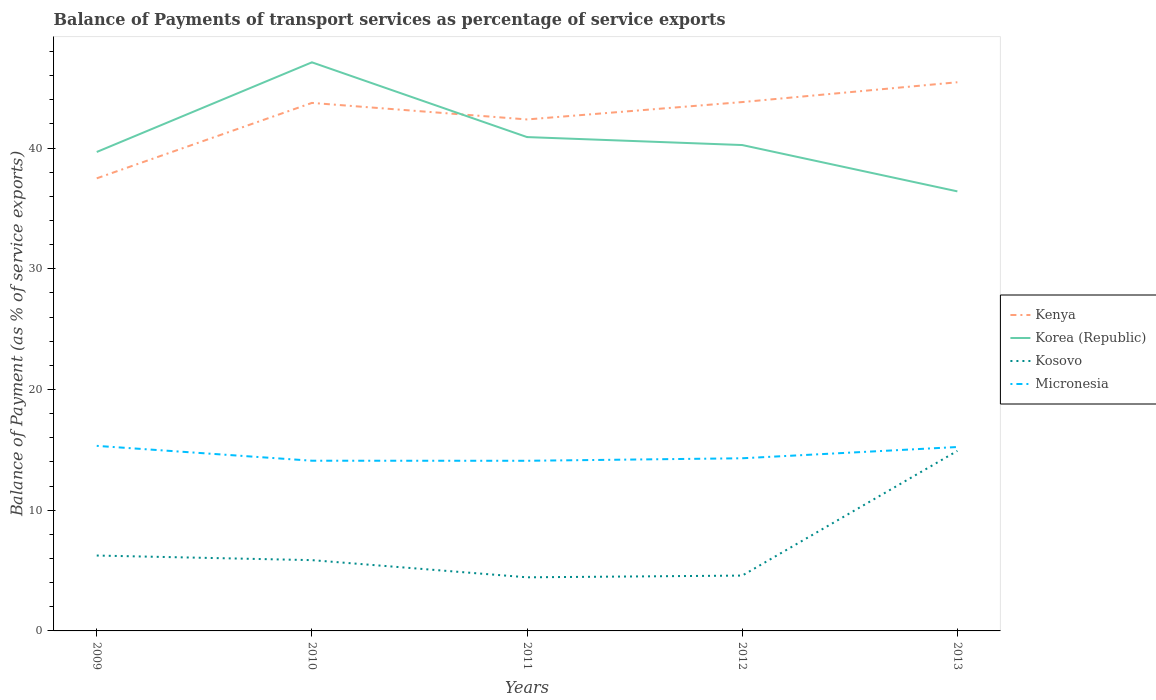How many different coloured lines are there?
Make the answer very short. 4. Across all years, what is the maximum balance of payments of transport services in Korea (Republic)?
Provide a short and direct response. 36.41. What is the total balance of payments of transport services in Korea (Republic) in the graph?
Your response must be concise. 0.66. What is the difference between the highest and the second highest balance of payments of transport services in Kenya?
Make the answer very short. 7.96. What is the difference between the highest and the lowest balance of payments of transport services in Korea (Republic)?
Keep it short and to the point. 2. How many years are there in the graph?
Your answer should be compact. 5. What is the difference between two consecutive major ticks on the Y-axis?
Your response must be concise. 10. Are the values on the major ticks of Y-axis written in scientific E-notation?
Give a very brief answer. No. How many legend labels are there?
Ensure brevity in your answer.  4. What is the title of the graph?
Provide a short and direct response. Balance of Payments of transport services as percentage of service exports. What is the label or title of the X-axis?
Provide a short and direct response. Years. What is the label or title of the Y-axis?
Offer a terse response. Balance of Payment (as % of service exports). What is the Balance of Payment (as % of service exports) of Kenya in 2009?
Your answer should be compact. 37.49. What is the Balance of Payment (as % of service exports) in Korea (Republic) in 2009?
Make the answer very short. 39.67. What is the Balance of Payment (as % of service exports) in Kosovo in 2009?
Your answer should be very brief. 6.24. What is the Balance of Payment (as % of service exports) in Micronesia in 2009?
Make the answer very short. 15.33. What is the Balance of Payment (as % of service exports) of Kenya in 2010?
Provide a short and direct response. 43.74. What is the Balance of Payment (as % of service exports) in Korea (Republic) in 2010?
Your answer should be compact. 47.1. What is the Balance of Payment (as % of service exports) in Kosovo in 2010?
Make the answer very short. 5.86. What is the Balance of Payment (as % of service exports) of Micronesia in 2010?
Provide a succinct answer. 14.1. What is the Balance of Payment (as % of service exports) of Kenya in 2011?
Give a very brief answer. 42.37. What is the Balance of Payment (as % of service exports) of Korea (Republic) in 2011?
Offer a very short reply. 40.91. What is the Balance of Payment (as % of service exports) in Kosovo in 2011?
Your response must be concise. 4.44. What is the Balance of Payment (as % of service exports) of Micronesia in 2011?
Ensure brevity in your answer.  14.09. What is the Balance of Payment (as % of service exports) of Kenya in 2012?
Offer a terse response. 43.81. What is the Balance of Payment (as % of service exports) of Korea (Republic) in 2012?
Your answer should be compact. 40.25. What is the Balance of Payment (as % of service exports) of Kosovo in 2012?
Ensure brevity in your answer.  4.58. What is the Balance of Payment (as % of service exports) of Micronesia in 2012?
Offer a terse response. 14.3. What is the Balance of Payment (as % of service exports) of Kenya in 2013?
Your answer should be compact. 45.45. What is the Balance of Payment (as % of service exports) of Korea (Republic) in 2013?
Your answer should be compact. 36.41. What is the Balance of Payment (as % of service exports) in Kosovo in 2013?
Ensure brevity in your answer.  14.91. What is the Balance of Payment (as % of service exports) of Micronesia in 2013?
Your answer should be very brief. 15.23. Across all years, what is the maximum Balance of Payment (as % of service exports) in Kenya?
Make the answer very short. 45.45. Across all years, what is the maximum Balance of Payment (as % of service exports) of Korea (Republic)?
Keep it short and to the point. 47.1. Across all years, what is the maximum Balance of Payment (as % of service exports) of Kosovo?
Ensure brevity in your answer.  14.91. Across all years, what is the maximum Balance of Payment (as % of service exports) in Micronesia?
Your response must be concise. 15.33. Across all years, what is the minimum Balance of Payment (as % of service exports) in Kenya?
Provide a succinct answer. 37.49. Across all years, what is the minimum Balance of Payment (as % of service exports) in Korea (Republic)?
Offer a very short reply. 36.41. Across all years, what is the minimum Balance of Payment (as % of service exports) in Kosovo?
Your answer should be compact. 4.44. Across all years, what is the minimum Balance of Payment (as % of service exports) in Micronesia?
Give a very brief answer. 14.09. What is the total Balance of Payment (as % of service exports) in Kenya in the graph?
Your response must be concise. 212.85. What is the total Balance of Payment (as % of service exports) in Korea (Republic) in the graph?
Offer a very short reply. 204.34. What is the total Balance of Payment (as % of service exports) of Kosovo in the graph?
Provide a succinct answer. 36.05. What is the total Balance of Payment (as % of service exports) of Micronesia in the graph?
Your answer should be compact. 73.06. What is the difference between the Balance of Payment (as % of service exports) of Kenya in 2009 and that in 2010?
Keep it short and to the point. -6.25. What is the difference between the Balance of Payment (as % of service exports) of Korea (Republic) in 2009 and that in 2010?
Offer a very short reply. -7.43. What is the difference between the Balance of Payment (as % of service exports) in Kosovo in 2009 and that in 2010?
Offer a very short reply. 0.38. What is the difference between the Balance of Payment (as % of service exports) in Micronesia in 2009 and that in 2010?
Your response must be concise. 1.23. What is the difference between the Balance of Payment (as % of service exports) of Kenya in 2009 and that in 2011?
Make the answer very short. -4.88. What is the difference between the Balance of Payment (as % of service exports) of Korea (Republic) in 2009 and that in 2011?
Provide a succinct answer. -1.23. What is the difference between the Balance of Payment (as % of service exports) in Kosovo in 2009 and that in 2011?
Ensure brevity in your answer.  1.8. What is the difference between the Balance of Payment (as % of service exports) in Micronesia in 2009 and that in 2011?
Keep it short and to the point. 1.24. What is the difference between the Balance of Payment (as % of service exports) of Kenya in 2009 and that in 2012?
Provide a short and direct response. -6.32. What is the difference between the Balance of Payment (as % of service exports) in Korea (Republic) in 2009 and that in 2012?
Offer a terse response. -0.57. What is the difference between the Balance of Payment (as % of service exports) in Kosovo in 2009 and that in 2012?
Keep it short and to the point. 1.66. What is the difference between the Balance of Payment (as % of service exports) in Micronesia in 2009 and that in 2012?
Keep it short and to the point. 1.03. What is the difference between the Balance of Payment (as % of service exports) in Kenya in 2009 and that in 2013?
Make the answer very short. -7.96. What is the difference between the Balance of Payment (as % of service exports) of Korea (Republic) in 2009 and that in 2013?
Offer a very short reply. 3.26. What is the difference between the Balance of Payment (as % of service exports) in Kosovo in 2009 and that in 2013?
Offer a very short reply. -8.67. What is the difference between the Balance of Payment (as % of service exports) of Micronesia in 2009 and that in 2013?
Provide a short and direct response. 0.1. What is the difference between the Balance of Payment (as % of service exports) in Kenya in 2010 and that in 2011?
Ensure brevity in your answer.  1.37. What is the difference between the Balance of Payment (as % of service exports) of Korea (Republic) in 2010 and that in 2011?
Provide a succinct answer. 6.19. What is the difference between the Balance of Payment (as % of service exports) of Kosovo in 2010 and that in 2011?
Ensure brevity in your answer.  1.42. What is the difference between the Balance of Payment (as % of service exports) of Micronesia in 2010 and that in 2011?
Offer a very short reply. 0.01. What is the difference between the Balance of Payment (as % of service exports) of Kenya in 2010 and that in 2012?
Your response must be concise. -0.07. What is the difference between the Balance of Payment (as % of service exports) in Korea (Republic) in 2010 and that in 2012?
Offer a terse response. 6.85. What is the difference between the Balance of Payment (as % of service exports) of Kosovo in 2010 and that in 2012?
Your response must be concise. 1.28. What is the difference between the Balance of Payment (as % of service exports) of Micronesia in 2010 and that in 2012?
Ensure brevity in your answer.  -0.2. What is the difference between the Balance of Payment (as % of service exports) of Kenya in 2010 and that in 2013?
Ensure brevity in your answer.  -1.71. What is the difference between the Balance of Payment (as % of service exports) in Korea (Republic) in 2010 and that in 2013?
Provide a succinct answer. 10.69. What is the difference between the Balance of Payment (as % of service exports) of Kosovo in 2010 and that in 2013?
Keep it short and to the point. -9.05. What is the difference between the Balance of Payment (as % of service exports) in Micronesia in 2010 and that in 2013?
Ensure brevity in your answer.  -1.14. What is the difference between the Balance of Payment (as % of service exports) in Kenya in 2011 and that in 2012?
Offer a very short reply. -1.44. What is the difference between the Balance of Payment (as % of service exports) of Korea (Republic) in 2011 and that in 2012?
Make the answer very short. 0.66. What is the difference between the Balance of Payment (as % of service exports) of Kosovo in 2011 and that in 2012?
Provide a succinct answer. -0.14. What is the difference between the Balance of Payment (as % of service exports) in Micronesia in 2011 and that in 2012?
Offer a terse response. -0.21. What is the difference between the Balance of Payment (as % of service exports) of Kenya in 2011 and that in 2013?
Provide a short and direct response. -3.08. What is the difference between the Balance of Payment (as % of service exports) in Korea (Republic) in 2011 and that in 2013?
Keep it short and to the point. 4.5. What is the difference between the Balance of Payment (as % of service exports) of Kosovo in 2011 and that in 2013?
Make the answer very short. -10.47. What is the difference between the Balance of Payment (as % of service exports) in Micronesia in 2011 and that in 2013?
Your response must be concise. -1.14. What is the difference between the Balance of Payment (as % of service exports) in Kenya in 2012 and that in 2013?
Keep it short and to the point. -1.64. What is the difference between the Balance of Payment (as % of service exports) in Korea (Republic) in 2012 and that in 2013?
Provide a short and direct response. 3.84. What is the difference between the Balance of Payment (as % of service exports) in Kosovo in 2012 and that in 2013?
Your answer should be very brief. -10.33. What is the difference between the Balance of Payment (as % of service exports) in Micronesia in 2012 and that in 2013?
Provide a short and direct response. -0.93. What is the difference between the Balance of Payment (as % of service exports) of Kenya in 2009 and the Balance of Payment (as % of service exports) of Korea (Republic) in 2010?
Offer a terse response. -9.61. What is the difference between the Balance of Payment (as % of service exports) of Kenya in 2009 and the Balance of Payment (as % of service exports) of Kosovo in 2010?
Your answer should be very brief. 31.63. What is the difference between the Balance of Payment (as % of service exports) of Kenya in 2009 and the Balance of Payment (as % of service exports) of Micronesia in 2010?
Provide a succinct answer. 23.39. What is the difference between the Balance of Payment (as % of service exports) of Korea (Republic) in 2009 and the Balance of Payment (as % of service exports) of Kosovo in 2010?
Offer a terse response. 33.81. What is the difference between the Balance of Payment (as % of service exports) of Korea (Republic) in 2009 and the Balance of Payment (as % of service exports) of Micronesia in 2010?
Your answer should be compact. 25.57. What is the difference between the Balance of Payment (as % of service exports) in Kosovo in 2009 and the Balance of Payment (as % of service exports) in Micronesia in 2010?
Make the answer very short. -7.85. What is the difference between the Balance of Payment (as % of service exports) in Kenya in 2009 and the Balance of Payment (as % of service exports) in Korea (Republic) in 2011?
Your response must be concise. -3.42. What is the difference between the Balance of Payment (as % of service exports) of Kenya in 2009 and the Balance of Payment (as % of service exports) of Kosovo in 2011?
Your answer should be compact. 33.05. What is the difference between the Balance of Payment (as % of service exports) of Kenya in 2009 and the Balance of Payment (as % of service exports) of Micronesia in 2011?
Your answer should be compact. 23.4. What is the difference between the Balance of Payment (as % of service exports) of Korea (Republic) in 2009 and the Balance of Payment (as % of service exports) of Kosovo in 2011?
Offer a terse response. 35.23. What is the difference between the Balance of Payment (as % of service exports) of Korea (Republic) in 2009 and the Balance of Payment (as % of service exports) of Micronesia in 2011?
Make the answer very short. 25.58. What is the difference between the Balance of Payment (as % of service exports) in Kosovo in 2009 and the Balance of Payment (as % of service exports) in Micronesia in 2011?
Provide a short and direct response. -7.85. What is the difference between the Balance of Payment (as % of service exports) of Kenya in 2009 and the Balance of Payment (as % of service exports) of Korea (Republic) in 2012?
Provide a short and direct response. -2.76. What is the difference between the Balance of Payment (as % of service exports) of Kenya in 2009 and the Balance of Payment (as % of service exports) of Kosovo in 2012?
Offer a terse response. 32.91. What is the difference between the Balance of Payment (as % of service exports) of Kenya in 2009 and the Balance of Payment (as % of service exports) of Micronesia in 2012?
Provide a short and direct response. 23.19. What is the difference between the Balance of Payment (as % of service exports) of Korea (Republic) in 2009 and the Balance of Payment (as % of service exports) of Kosovo in 2012?
Your response must be concise. 35.09. What is the difference between the Balance of Payment (as % of service exports) of Korea (Republic) in 2009 and the Balance of Payment (as % of service exports) of Micronesia in 2012?
Give a very brief answer. 25.37. What is the difference between the Balance of Payment (as % of service exports) of Kosovo in 2009 and the Balance of Payment (as % of service exports) of Micronesia in 2012?
Your response must be concise. -8.06. What is the difference between the Balance of Payment (as % of service exports) of Kenya in 2009 and the Balance of Payment (as % of service exports) of Korea (Republic) in 2013?
Make the answer very short. 1.08. What is the difference between the Balance of Payment (as % of service exports) in Kenya in 2009 and the Balance of Payment (as % of service exports) in Kosovo in 2013?
Provide a short and direct response. 22.58. What is the difference between the Balance of Payment (as % of service exports) in Kenya in 2009 and the Balance of Payment (as % of service exports) in Micronesia in 2013?
Your answer should be very brief. 22.26. What is the difference between the Balance of Payment (as % of service exports) of Korea (Republic) in 2009 and the Balance of Payment (as % of service exports) of Kosovo in 2013?
Ensure brevity in your answer.  24.76. What is the difference between the Balance of Payment (as % of service exports) in Korea (Republic) in 2009 and the Balance of Payment (as % of service exports) in Micronesia in 2013?
Your answer should be compact. 24.44. What is the difference between the Balance of Payment (as % of service exports) of Kosovo in 2009 and the Balance of Payment (as % of service exports) of Micronesia in 2013?
Ensure brevity in your answer.  -8.99. What is the difference between the Balance of Payment (as % of service exports) of Kenya in 2010 and the Balance of Payment (as % of service exports) of Korea (Republic) in 2011?
Provide a short and direct response. 2.83. What is the difference between the Balance of Payment (as % of service exports) of Kenya in 2010 and the Balance of Payment (as % of service exports) of Kosovo in 2011?
Give a very brief answer. 39.3. What is the difference between the Balance of Payment (as % of service exports) in Kenya in 2010 and the Balance of Payment (as % of service exports) in Micronesia in 2011?
Offer a terse response. 29.64. What is the difference between the Balance of Payment (as % of service exports) of Korea (Republic) in 2010 and the Balance of Payment (as % of service exports) of Kosovo in 2011?
Provide a short and direct response. 42.66. What is the difference between the Balance of Payment (as % of service exports) in Korea (Republic) in 2010 and the Balance of Payment (as % of service exports) in Micronesia in 2011?
Offer a terse response. 33.01. What is the difference between the Balance of Payment (as % of service exports) in Kosovo in 2010 and the Balance of Payment (as % of service exports) in Micronesia in 2011?
Your response must be concise. -8.23. What is the difference between the Balance of Payment (as % of service exports) of Kenya in 2010 and the Balance of Payment (as % of service exports) of Korea (Republic) in 2012?
Provide a short and direct response. 3.49. What is the difference between the Balance of Payment (as % of service exports) in Kenya in 2010 and the Balance of Payment (as % of service exports) in Kosovo in 2012?
Offer a terse response. 39.15. What is the difference between the Balance of Payment (as % of service exports) of Kenya in 2010 and the Balance of Payment (as % of service exports) of Micronesia in 2012?
Your answer should be very brief. 29.44. What is the difference between the Balance of Payment (as % of service exports) of Korea (Republic) in 2010 and the Balance of Payment (as % of service exports) of Kosovo in 2012?
Offer a terse response. 42.52. What is the difference between the Balance of Payment (as % of service exports) in Korea (Republic) in 2010 and the Balance of Payment (as % of service exports) in Micronesia in 2012?
Keep it short and to the point. 32.8. What is the difference between the Balance of Payment (as % of service exports) of Kosovo in 2010 and the Balance of Payment (as % of service exports) of Micronesia in 2012?
Ensure brevity in your answer.  -8.44. What is the difference between the Balance of Payment (as % of service exports) in Kenya in 2010 and the Balance of Payment (as % of service exports) in Korea (Republic) in 2013?
Give a very brief answer. 7.33. What is the difference between the Balance of Payment (as % of service exports) in Kenya in 2010 and the Balance of Payment (as % of service exports) in Kosovo in 2013?
Offer a very short reply. 28.82. What is the difference between the Balance of Payment (as % of service exports) of Kenya in 2010 and the Balance of Payment (as % of service exports) of Micronesia in 2013?
Your answer should be very brief. 28.5. What is the difference between the Balance of Payment (as % of service exports) in Korea (Republic) in 2010 and the Balance of Payment (as % of service exports) in Kosovo in 2013?
Offer a very short reply. 32.19. What is the difference between the Balance of Payment (as % of service exports) of Korea (Republic) in 2010 and the Balance of Payment (as % of service exports) of Micronesia in 2013?
Your answer should be very brief. 31.87. What is the difference between the Balance of Payment (as % of service exports) of Kosovo in 2010 and the Balance of Payment (as % of service exports) of Micronesia in 2013?
Provide a succinct answer. -9.37. What is the difference between the Balance of Payment (as % of service exports) of Kenya in 2011 and the Balance of Payment (as % of service exports) of Korea (Republic) in 2012?
Offer a terse response. 2.12. What is the difference between the Balance of Payment (as % of service exports) of Kenya in 2011 and the Balance of Payment (as % of service exports) of Kosovo in 2012?
Provide a short and direct response. 37.78. What is the difference between the Balance of Payment (as % of service exports) of Kenya in 2011 and the Balance of Payment (as % of service exports) of Micronesia in 2012?
Give a very brief answer. 28.07. What is the difference between the Balance of Payment (as % of service exports) of Korea (Republic) in 2011 and the Balance of Payment (as % of service exports) of Kosovo in 2012?
Your answer should be compact. 36.32. What is the difference between the Balance of Payment (as % of service exports) of Korea (Republic) in 2011 and the Balance of Payment (as % of service exports) of Micronesia in 2012?
Give a very brief answer. 26.61. What is the difference between the Balance of Payment (as % of service exports) in Kosovo in 2011 and the Balance of Payment (as % of service exports) in Micronesia in 2012?
Ensure brevity in your answer.  -9.86. What is the difference between the Balance of Payment (as % of service exports) in Kenya in 2011 and the Balance of Payment (as % of service exports) in Korea (Republic) in 2013?
Offer a very short reply. 5.96. What is the difference between the Balance of Payment (as % of service exports) of Kenya in 2011 and the Balance of Payment (as % of service exports) of Kosovo in 2013?
Offer a terse response. 27.45. What is the difference between the Balance of Payment (as % of service exports) in Kenya in 2011 and the Balance of Payment (as % of service exports) in Micronesia in 2013?
Your answer should be very brief. 27.13. What is the difference between the Balance of Payment (as % of service exports) in Korea (Republic) in 2011 and the Balance of Payment (as % of service exports) in Kosovo in 2013?
Your response must be concise. 25.99. What is the difference between the Balance of Payment (as % of service exports) of Korea (Republic) in 2011 and the Balance of Payment (as % of service exports) of Micronesia in 2013?
Your answer should be compact. 25.67. What is the difference between the Balance of Payment (as % of service exports) in Kosovo in 2011 and the Balance of Payment (as % of service exports) in Micronesia in 2013?
Provide a short and direct response. -10.79. What is the difference between the Balance of Payment (as % of service exports) in Kenya in 2012 and the Balance of Payment (as % of service exports) in Korea (Republic) in 2013?
Provide a succinct answer. 7.4. What is the difference between the Balance of Payment (as % of service exports) in Kenya in 2012 and the Balance of Payment (as % of service exports) in Kosovo in 2013?
Keep it short and to the point. 28.89. What is the difference between the Balance of Payment (as % of service exports) of Kenya in 2012 and the Balance of Payment (as % of service exports) of Micronesia in 2013?
Offer a very short reply. 28.57. What is the difference between the Balance of Payment (as % of service exports) of Korea (Republic) in 2012 and the Balance of Payment (as % of service exports) of Kosovo in 2013?
Offer a very short reply. 25.33. What is the difference between the Balance of Payment (as % of service exports) in Korea (Republic) in 2012 and the Balance of Payment (as % of service exports) in Micronesia in 2013?
Give a very brief answer. 25.01. What is the difference between the Balance of Payment (as % of service exports) of Kosovo in 2012 and the Balance of Payment (as % of service exports) of Micronesia in 2013?
Keep it short and to the point. -10.65. What is the average Balance of Payment (as % of service exports) in Kenya per year?
Offer a terse response. 42.57. What is the average Balance of Payment (as % of service exports) of Korea (Republic) per year?
Your answer should be very brief. 40.87. What is the average Balance of Payment (as % of service exports) of Kosovo per year?
Make the answer very short. 7.21. What is the average Balance of Payment (as % of service exports) of Micronesia per year?
Provide a short and direct response. 14.61. In the year 2009, what is the difference between the Balance of Payment (as % of service exports) of Kenya and Balance of Payment (as % of service exports) of Korea (Republic)?
Your answer should be very brief. -2.18. In the year 2009, what is the difference between the Balance of Payment (as % of service exports) of Kenya and Balance of Payment (as % of service exports) of Kosovo?
Provide a short and direct response. 31.25. In the year 2009, what is the difference between the Balance of Payment (as % of service exports) of Kenya and Balance of Payment (as % of service exports) of Micronesia?
Provide a succinct answer. 22.16. In the year 2009, what is the difference between the Balance of Payment (as % of service exports) in Korea (Republic) and Balance of Payment (as % of service exports) in Kosovo?
Offer a very short reply. 33.43. In the year 2009, what is the difference between the Balance of Payment (as % of service exports) of Korea (Republic) and Balance of Payment (as % of service exports) of Micronesia?
Your answer should be compact. 24.34. In the year 2009, what is the difference between the Balance of Payment (as % of service exports) in Kosovo and Balance of Payment (as % of service exports) in Micronesia?
Offer a very short reply. -9.08. In the year 2010, what is the difference between the Balance of Payment (as % of service exports) in Kenya and Balance of Payment (as % of service exports) in Korea (Republic)?
Your response must be concise. -3.36. In the year 2010, what is the difference between the Balance of Payment (as % of service exports) of Kenya and Balance of Payment (as % of service exports) of Kosovo?
Offer a very short reply. 37.87. In the year 2010, what is the difference between the Balance of Payment (as % of service exports) of Kenya and Balance of Payment (as % of service exports) of Micronesia?
Your response must be concise. 29.64. In the year 2010, what is the difference between the Balance of Payment (as % of service exports) in Korea (Republic) and Balance of Payment (as % of service exports) in Kosovo?
Keep it short and to the point. 41.24. In the year 2010, what is the difference between the Balance of Payment (as % of service exports) of Korea (Republic) and Balance of Payment (as % of service exports) of Micronesia?
Your answer should be compact. 33. In the year 2010, what is the difference between the Balance of Payment (as % of service exports) in Kosovo and Balance of Payment (as % of service exports) in Micronesia?
Offer a very short reply. -8.24. In the year 2011, what is the difference between the Balance of Payment (as % of service exports) in Kenya and Balance of Payment (as % of service exports) in Korea (Republic)?
Provide a succinct answer. 1.46. In the year 2011, what is the difference between the Balance of Payment (as % of service exports) of Kenya and Balance of Payment (as % of service exports) of Kosovo?
Give a very brief answer. 37.93. In the year 2011, what is the difference between the Balance of Payment (as % of service exports) in Kenya and Balance of Payment (as % of service exports) in Micronesia?
Your answer should be very brief. 28.27. In the year 2011, what is the difference between the Balance of Payment (as % of service exports) of Korea (Republic) and Balance of Payment (as % of service exports) of Kosovo?
Your answer should be compact. 36.47. In the year 2011, what is the difference between the Balance of Payment (as % of service exports) of Korea (Republic) and Balance of Payment (as % of service exports) of Micronesia?
Your answer should be very brief. 26.81. In the year 2011, what is the difference between the Balance of Payment (as % of service exports) of Kosovo and Balance of Payment (as % of service exports) of Micronesia?
Your response must be concise. -9.65. In the year 2012, what is the difference between the Balance of Payment (as % of service exports) in Kenya and Balance of Payment (as % of service exports) in Korea (Republic)?
Provide a succinct answer. 3.56. In the year 2012, what is the difference between the Balance of Payment (as % of service exports) of Kenya and Balance of Payment (as % of service exports) of Kosovo?
Offer a very short reply. 39.22. In the year 2012, what is the difference between the Balance of Payment (as % of service exports) of Kenya and Balance of Payment (as % of service exports) of Micronesia?
Keep it short and to the point. 29.51. In the year 2012, what is the difference between the Balance of Payment (as % of service exports) in Korea (Republic) and Balance of Payment (as % of service exports) in Kosovo?
Your response must be concise. 35.66. In the year 2012, what is the difference between the Balance of Payment (as % of service exports) of Korea (Republic) and Balance of Payment (as % of service exports) of Micronesia?
Keep it short and to the point. 25.95. In the year 2012, what is the difference between the Balance of Payment (as % of service exports) in Kosovo and Balance of Payment (as % of service exports) in Micronesia?
Make the answer very short. -9.72. In the year 2013, what is the difference between the Balance of Payment (as % of service exports) of Kenya and Balance of Payment (as % of service exports) of Korea (Republic)?
Provide a short and direct response. 9.04. In the year 2013, what is the difference between the Balance of Payment (as % of service exports) of Kenya and Balance of Payment (as % of service exports) of Kosovo?
Offer a terse response. 30.53. In the year 2013, what is the difference between the Balance of Payment (as % of service exports) of Kenya and Balance of Payment (as % of service exports) of Micronesia?
Provide a short and direct response. 30.22. In the year 2013, what is the difference between the Balance of Payment (as % of service exports) in Korea (Republic) and Balance of Payment (as % of service exports) in Kosovo?
Your answer should be compact. 21.5. In the year 2013, what is the difference between the Balance of Payment (as % of service exports) in Korea (Republic) and Balance of Payment (as % of service exports) in Micronesia?
Make the answer very short. 21.18. In the year 2013, what is the difference between the Balance of Payment (as % of service exports) of Kosovo and Balance of Payment (as % of service exports) of Micronesia?
Your answer should be very brief. -0.32. What is the ratio of the Balance of Payment (as % of service exports) of Kenya in 2009 to that in 2010?
Provide a succinct answer. 0.86. What is the ratio of the Balance of Payment (as % of service exports) of Korea (Republic) in 2009 to that in 2010?
Ensure brevity in your answer.  0.84. What is the ratio of the Balance of Payment (as % of service exports) of Kosovo in 2009 to that in 2010?
Give a very brief answer. 1.07. What is the ratio of the Balance of Payment (as % of service exports) in Micronesia in 2009 to that in 2010?
Keep it short and to the point. 1.09. What is the ratio of the Balance of Payment (as % of service exports) of Kenya in 2009 to that in 2011?
Your answer should be very brief. 0.88. What is the ratio of the Balance of Payment (as % of service exports) of Korea (Republic) in 2009 to that in 2011?
Give a very brief answer. 0.97. What is the ratio of the Balance of Payment (as % of service exports) of Kosovo in 2009 to that in 2011?
Your answer should be compact. 1.41. What is the ratio of the Balance of Payment (as % of service exports) of Micronesia in 2009 to that in 2011?
Your response must be concise. 1.09. What is the ratio of the Balance of Payment (as % of service exports) of Kenya in 2009 to that in 2012?
Your answer should be compact. 0.86. What is the ratio of the Balance of Payment (as % of service exports) of Korea (Republic) in 2009 to that in 2012?
Provide a succinct answer. 0.99. What is the ratio of the Balance of Payment (as % of service exports) of Kosovo in 2009 to that in 2012?
Offer a very short reply. 1.36. What is the ratio of the Balance of Payment (as % of service exports) of Micronesia in 2009 to that in 2012?
Provide a succinct answer. 1.07. What is the ratio of the Balance of Payment (as % of service exports) of Kenya in 2009 to that in 2013?
Provide a succinct answer. 0.82. What is the ratio of the Balance of Payment (as % of service exports) in Korea (Republic) in 2009 to that in 2013?
Give a very brief answer. 1.09. What is the ratio of the Balance of Payment (as % of service exports) of Kosovo in 2009 to that in 2013?
Your answer should be very brief. 0.42. What is the ratio of the Balance of Payment (as % of service exports) of Micronesia in 2009 to that in 2013?
Offer a very short reply. 1.01. What is the ratio of the Balance of Payment (as % of service exports) in Kenya in 2010 to that in 2011?
Give a very brief answer. 1.03. What is the ratio of the Balance of Payment (as % of service exports) of Korea (Republic) in 2010 to that in 2011?
Offer a very short reply. 1.15. What is the ratio of the Balance of Payment (as % of service exports) in Kosovo in 2010 to that in 2011?
Your answer should be compact. 1.32. What is the ratio of the Balance of Payment (as % of service exports) of Micronesia in 2010 to that in 2011?
Give a very brief answer. 1. What is the ratio of the Balance of Payment (as % of service exports) of Korea (Republic) in 2010 to that in 2012?
Give a very brief answer. 1.17. What is the ratio of the Balance of Payment (as % of service exports) of Kosovo in 2010 to that in 2012?
Give a very brief answer. 1.28. What is the ratio of the Balance of Payment (as % of service exports) in Micronesia in 2010 to that in 2012?
Make the answer very short. 0.99. What is the ratio of the Balance of Payment (as % of service exports) in Kenya in 2010 to that in 2013?
Make the answer very short. 0.96. What is the ratio of the Balance of Payment (as % of service exports) of Korea (Republic) in 2010 to that in 2013?
Offer a terse response. 1.29. What is the ratio of the Balance of Payment (as % of service exports) in Kosovo in 2010 to that in 2013?
Provide a short and direct response. 0.39. What is the ratio of the Balance of Payment (as % of service exports) in Micronesia in 2010 to that in 2013?
Ensure brevity in your answer.  0.93. What is the ratio of the Balance of Payment (as % of service exports) in Kenya in 2011 to that in 2012?
Your answer should be compact. 0.97. What is the ratio of the Balance of Payment (as % of service exports) in Korea (Republic) in 2011 to that in 2012?
Your answer should be compact. 1.02. What is the ratio of the Balance of Payment (as % of service exports) of Kosovo in 2011 to that in 2012?
Keep it short and to the point. 0.97. What is the ratio of the Balance of Payment (as % of service exports) of Micronesia in 2011 to that in 2012?
Offer a very short reply. 0.99. What is the ratio of the Balance of Payment (as % of service exports) of Kenya in 2011 to that in 2013?
Your answer should be very brief. 0.93. What is the ratio of the Balance of Payment (as % of service exports) of Korea (Republic) in 2011 to that in 2013?
Make the answer very short. 1.12. What is the ratio of the Balance of Payment (as % of service exports) in Kosovo in 2011 to that in 2013?
Make the answer very short. 0.3. What is the ratio of the Balance of Payment (as % of service exports) in Micronesia in 2011 to that in 2013?
Your answer should be very brief. 0.93. What is the ratio of the Balance of Payment (as % of service exports) of Kenya in 2012 to that in 2013?
Your answer should be very brief. 0.96. What is the ratio of the Balance of Payment (as % of service exports) in Korea (Republic) in 2012 to that in 2013?
Keep it short and to the point. 1.11. What is the ratio of the Balance of Payment (as % of service exports) of Kosovo in 2012 to that in 2013?
Make the answer very short. 0.31. What is the ratio of the Balance of Payment (as % of service exports) in Micronesia in 2012 to that in 2013?
Ensure brevity in your answer.  0.94. What is the difference between the highest and the second highest Balance of Payment (as % of service exports) in Kenya?
Your response must be concise. 1.64. What is the difference between the highest and the second highest Balance of Payment (as % of service exports) in Korea (Republic)?
Keep it short and to the point. 6.19. What is the difference between the highest and the second highest Balance of Payment (as % of service exports) of Kosovo?
Provide a short and direct response. 8.67. What is the difference between the highest and the second highest Balance of Payment (as % of service exports) in Micronesia?
Your answer should be compact. 0.1. What is the difference between the highest and the lowest Balance of Payment (as % of service exports) of Kenya?
Your answer should be very brief. 7.96. What is the difference between the highest and the lowest Balance of Payment (as % of service exports) in Korea (Republic)?
Provide a succinct answer. 10.69. What is the difference between the highest and the lowest Balance of Payment (as % of service exports) of Kosovo?
Provide a short and direct response. 10.47. What is the difference between the highest and the lowest Balance of Payment (as % of service exports) in Micronesia?
Provide a succinct answer. 1.24. 